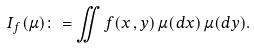<formula> <loc_0><loc_0><loc_500><loc_500>I _ { f } ( \mu ) \colon = \iint f ( x \, , y ) \, \mu ( d x ) \, \mu ( d y ) .</formula> 